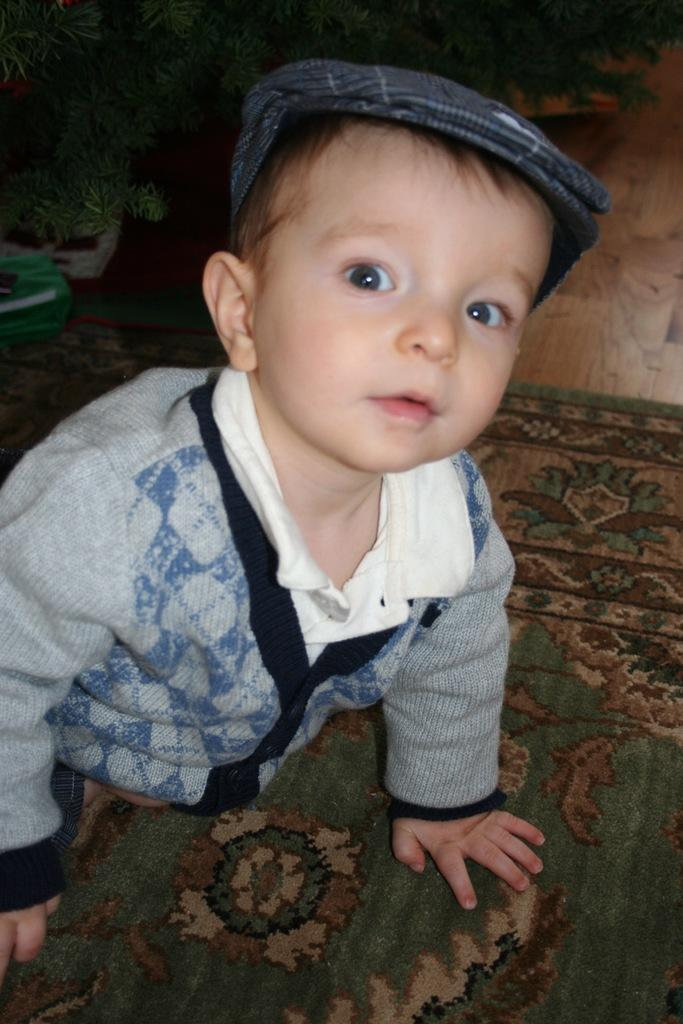What is the main subject in the foreground of the image? There is a boy in the foreground of the image. What is the boy doing or sitting on in the image? The boy is on a mat in the image. What type of vegetation can be seen at the top of the image? There are plants visible at the top of the image. What type of flooring is present in the image? There is a wooden floor in the image. What type of drink is the boy holding in the image? There is no drink visible in the image; the boy is sitting on a mat. What nation does the boy in the image desire to visit? There is no information about the boy's desires or travel plans in the image. 